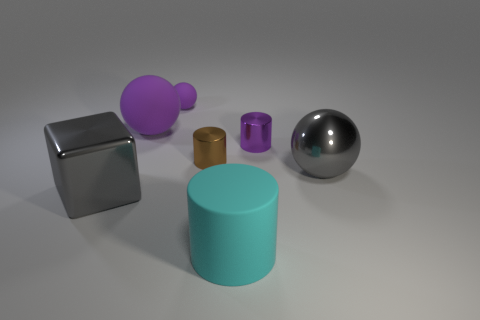Add 2 rubber cylinders. How many objects exist? 9 Subtract all cubes. How many objects are left? 6 Add 6 purple cylinders. How many purple cylinders are left? 7 Add 6 gray balls. How many gray balls exist? 7 Subtract 0 brown balls. How many objects are left? 7 Subtract all big red matte cylinders. Subtract all small rubber objects. How many objects are left? 6 